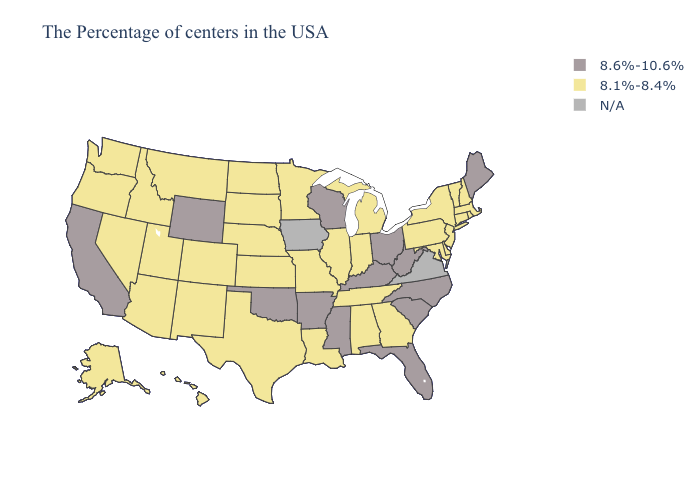What is the lowest value in the MidWest?
Answer briefly. 8.1%-8.4%. Which states have the highest value in the USA?
Be succinct. Maine, North Carolina, South Carolina, West Virginia, Ohio, Florida, Kentucky, Wisconsin, Mississippi, Arkansas, Oklahoma, Wyoming, California. Name the states that have a value in the range 8.6%-10.6%?
Answer briefly. Maine, North Carolina, South Carolina, West Virginia, Ohio, Florida, Kentucky, Wisconsin, Mississippi, Arkansas, Oklahoma, Wyoming, California. What is the value of Tennessee?
Short answer required. 8.1%-8.4%. Name the states that have a value in the range 8.6%-10.6%?
Quick response, please. Maine, North Carolina, South Carolina, West Virginia, Ohio, Florida, Kentucky, Wisconsin, Mississippi, Arkansas, Oklahoma, Wyoming, California. Name the states that have a value in the range 8.1%-8.4%?
Short answer required. Massachusetts, Rhode Island, New Hampshire, Vermont, Connecticut, New York, New Jersey, Delaware, Maryland, Pennsylvania, Georgia, Michigan, Indiana, Alabama, Tennessee, Illinois, Louisiana, Missouri, Minnesota, Kansas, Nebraska, Texas, South Dakota, North Dakota, Colorado, New Mexico, Utah, Montana, Arizona, Idaho, Nevada, Washington, Oregon, Alaska, Hawaii. Does the map have missing data?
Answer briefly. Yes. Which states have the lowest value in the USA?
Give a very brief answer. Massachusetts, Rhode Island, New Hampshire, Vermont, Connecticut, New York, New Jersey, Delaware, Maryland, Pennsylvania, Georgia, Michigan, Indiana, Alabama, Tennessee, Illinois, Louisiana, Missouri, Minnesota, Kansas, Nebraska, Texas, South Dakota, North Dakota, Colorado, New Mexico, Utah, Montana, Arizona, Idaho, Nevada, Washington, Oregon, Alaska, Hawaii. Which states hav the highest value in the West?
Concise answer only. Wyoming, California. Name the states that have a value in the range 8.6%-10.6%?
Short answer required. Maine, North Carolina, South Carolina, West Virginia, Ohio, Florida, Kentucky, Wisconsin, Mississippi, Arkansas, Oklahoma, Wyoming, California. What is the highest value in the MidWest ?
Short answer required. 8.6%-10.6%. Is the legend a continuous bar?
Give a very brief answer. No. What is the highest value in the USA?
Keep it brief. 8.6%-10.6%. 